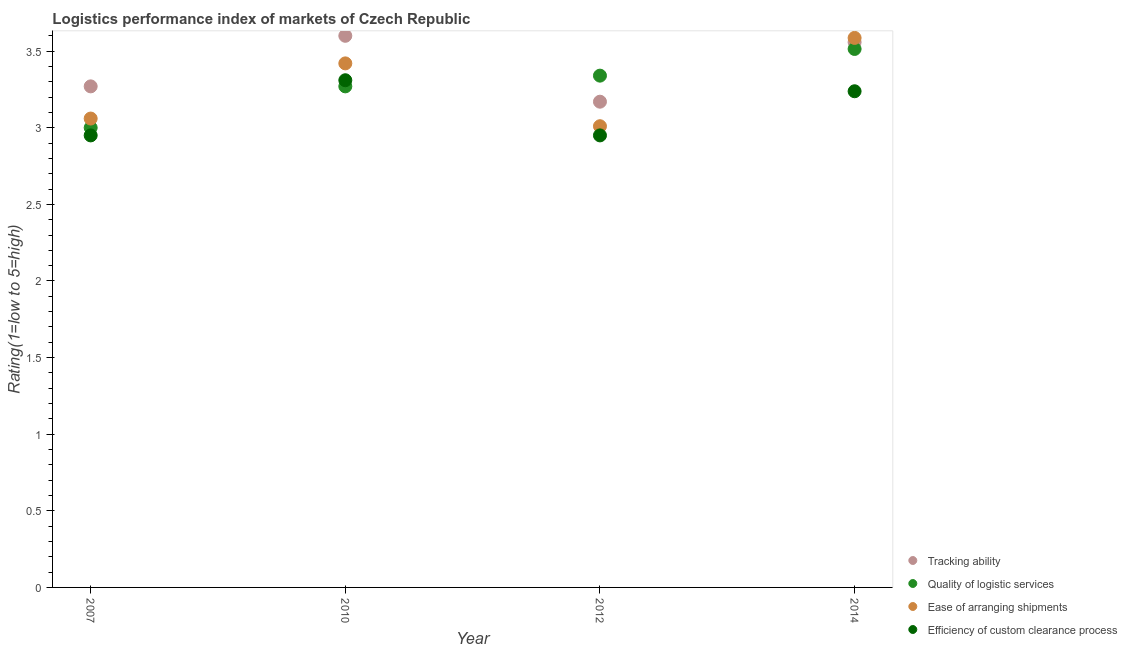How many different coloured dotlines are there?
Keep it short and to the point. 4. What is the lpi rating of efficiency of custom clearance process in 2014?
Provide a succinct answer. 3.24. Across all years, what is the maximum lpi rating of quality of logistic services?
Give a very brief answer. 3.51. In which year was the lpi rating of ease of arranging shipments maximum?
Provide a succinct answer. 2014. What is the total lpi rating of efficiency of custom clearance process in the graph?
Ensure brevity in your answer.  12.45. What is the difference between the lpi rating of tracking ability in 2007 and that in 2014?
Make the answer very short. -0.29. What is the difference between the lpi rating of efficiency of custom clearance process in 2014 and the lpi rating of tracking ability in 2012?
Your response must be concise. 0.07. What is the average lpi rating of quality of logistic services per year?
Your answer should be very brief. 3.28. In the year 2007, what is the difference between the lpi rating of quality of logistic services and lpi rating of tracking ability?
Provide a succinct answer. -0.27. What is the ratio of the lpi rating of efficiency of custom clearance process in 2012 to that in 2014?
Offer a terse response. 0.91. Is the lpi rating of efficiency of custom clearance process in 2007 less than that in 2012?
Offer a terse response. No. Is the difference between the lpi rating of ease of arranging shipments in 2007 and 2010 greater than the difference between the lpi rating of quality of logistic services in 2007 and 2010?
Offer a very short reply. No. What is the difference between the highest and the second highest lpi rating of quality of logistic services?
Keep it short and to the point. 0.17. What is the difference between the highest and the lowest lpi rating of efficiency of custom clearance process?
Make the answer very short. 0.36. Is the sum of the lpi rating of ease of arranging shipments in 2010 and 2012 greater than the maximum lpi rating of quality of logistic services across all years?
Ensure brevity in your answer.  Yes. Is it the case that in every year, the sum of the lpi rating of quality of logistic services and lpi rating of efficiency of custom clearance process is greater than the sum of lpi rating of tracking ability and lpi rating of ease of arranging shipments?
Give a very brief answer. No. Is it the case that in every year, the sum of the lpi rating of tracking ability and lpi rating of quality of logistic services is greater than the lpi rating of ease of arranging shipments?
Your answer should be very brief. Yes. Does the lpi rating of quality of logistic services monotonically increase over the years?
Provide a succinct answer. Yes. Is the lpi rating of tracking ability strictly less than the lpi rating of ease of arranging shipments over the years?
Your answer should be very brief. No. How many dotlines are there?
Provide a succinct answer. 4. What is the difference between two consecutive major ticks on the Y-axis?
Your response must be concise. 0.5. Does the graph contain any zero values?
Keep it short and to the point. No. Where does the legend appear in the graph?
Offer a terse response. Bottom right. How are the legend labels stacked?
Your answer should be very brief. Vertical. What is the title of the graph?
Keep it short and to the point. Logistics performance index of markets of Czech Republic. What is the label or title of the Y-axis?
Ensure brevity in your answer.  Rating(1=low to 5=high). What is the Rating(1=low to 5=high) of Tracking ability in 2007?
Provide a succinct answer. 3.27. What is the Rating(1=low to 5=high) of Quality of logistic services in 2007?
Your answer should be compact. 3. What is the Rating(1=low to 5=high) of Ease of arranging shipments in 2007?
Give a very brief answer. 3.06. What is the Rating(1=low to 5=high) of Efficiency of custom clearance process in 2007?
Ensure brevity in your answer.  2.95. What is the Rating(1=low to 5=high) of Quality of logistic services in 2010?
Provide a succinct answer. 3.27. What is the Rating(1=low to 5=high) in Ease of arranging shipments in 2010?
Your answer should be compact. 3.42. What is the Rating(1=low to 5=high) of Efficiency of custom clearance process in 2010?
Offer a very short reply. 3.31. What is the Rating(1=low to 5=high) of Tracking ability in 2012?
Offer a very short reply. 3.17. What is the Rating(1=low to 5=high) of Quality of logistic services in 2012?
Your response must be concise. 3.34. What is the Rating(1=low to 5=high) in Ease of arranging shipments in 2012?
Make the answer very short. 3.01. What is the Rating(1=low to 5=high) of Efficiency of custom clearance process in 2012?
Offer a very short reply. 2.95. What is the Rating(1=low to 5=high) of Tracking ability in 2014?
Offer a very short reply. 3.56. What is the Rating(1=low to 5=high) of Quality of logistic services in 2014?
Your answer should be compact. 3.51. What is the Rating(1=low to 5=high) of Ease of arranging shipments in 2014?
Offer a terse response. 3.59. What is the Rating(1=low to 5=high) of Efficiency of custom clearance process in 2014?
Your answer should be compact. 3.24. Across all years, what is the maximum Rating(1=low to 5=high) in Quality of logistic services?
Offer a very short reply. 3.51. Across all years, what is the maximum Rating(1=low to 5=high) in Ease of arranging shipments?
Give a very brief answer. 3.59. Across all years, what is the maximum Rating(1=low to 5=high) in Efficiency of custom clearance process?
Offer a very short reply. 3.31. Across all years, what is the minimum Rating(1=low to 5=high) in Tracking ability?
Your answer should be compact. 3.17. Across all years, what is the minimum Rating(1=low to 5=high) of Quality of logistic services?
Your response must be concise. 3. Across all years, what is the minimum Rating(1=low to 5=high) in Ease of arranging shipments?
Keep it short and to the point. 3.01. Across all years, what is the minimum Rating(1=low to 5=high) of Efficiency of custom clearance process?
Offer a very short reply. 2.95. What is the total Rating(1=low to 5=high) in Tracking ability in the graph?
Keep it short and to the point. 13.6. What is the total Rating(1=low to 5=high) of Quality of logistic services in the graph?
Keep it short and to the point. 13.12. What is the total Rating(1=low to 5=high) in Ease of arranging shipments in the graph?
Offer a terse response. 13.08. What is the total Rating(1=low to 5=high) in Efficiency of custom clearance process in the graph?
Offer a terse response. 12.45. What is the difference between the Rating(1=low to 5=high) in Tracking ability in 2007 and that in 2010?
Your response must be concise. -0.33. What is the difference between the Rating(1=low to 5=high) in Quality of logistic services in 2007 and that in 2010?
Your answer should be very brief. -0.27. What is the difference between the Rating(1=low to 5=high) in Ease of arranging shipments in 2007 and that in 2010?
Give a very brief answer. -0.36. What is the difference between the Rating(1=low to 5=high) of Efficiency of custom clearance process in 2007 and that in 2010?
Make the answer very short. -0.36. What is the difference between the Rating(1=low to 5=high) in Quality of logistic services in 2007 and that in 2012?
Ensure brevity in your answer.  -0.34. What is the difference between the Rating(1=low to 5=high) in Ease of arranging shipments in 2007 and that in 2012?
Your answer should be very brief. 0.05. What is the difference between the Rating(1=low to 5=high) in Efficiency of custom clearance process in 2007 and that in 2012?
Provide a short and direct response. 0. What is the difference between the Rating(1=low to 5=high) of Tracking ability in 2007 and that in 2014?
Provide a short and direct response. -0.29. What is the difference between the Rating(1=low to 5=high) in Quality of logistic services in 2007 and that in 2014?
Offer a very short reply. -0.51. What is the difference between the Rating(1=low to 5=high) in Ease of arranging shipments in 2007 and that in 2014?
Your answer should be compact. -0.53. What is the difference between the Rating(1=low to 5=high) of Efficiency of custom clearance process in 2007 and that in 2014?
Make the answer very short. -0.29. What is the difference between the Rating(1=low to 5=high) in Tracking ability in 2010 and that in 2012?
Your answer should be compact. 0.43. What is the difference between the Rating(1=low to 5=high) in Quality of logistic services in 2010 and that in 2012?
Provide a short and direct response. -0.07. What is the difference between the Rating(1=low to 5=high) of Ease of arranging shipments in 2010 and that in 2012?
Offer a very short reply. 0.41. What is the difference between the Rating(1=low to 5=high) in Efficiency of custom clearance process in 2010 and that in 2012?
Your answer should be very brief. 0.36. What is the difference between the Rating(1=low to 5=high) in Tracking ability in 2010 and that in 2014?
Make the answer very short. 0.04. What is the difference between the Rating(1=low to 5=high) of Quality of logistic services in 2010 and that in 2014?
Your response must be concise. -0.24. What is the difference between the Rating(1=low to 5=high) in Ease of arranging shipments in 2010 and that in 2014?
Ensure brevity in your answer.  -0.17. What is the difference between the Rating(1=low to 5=high) in Efficiency of custom clearance process in 2010 and that in 2014?
Your answer should be compact. 0.07. What is the difference between the Rating(1=low to 5=high) in Tracking ability in 2012 and that in 2014?
Provide a short and direct response. -0.39. What is the difference between the Rating(1=low to 5=high) of Quality of logistic services in 2012 and that in 2014?
Offer a terse response. -0.17. What is the difference between the Rating(1=low to 5=high) in Ease of arranging shipments in 2012 and that in 2014?
Your answer should be very brief. -0.58. What is the difference between the Rating(1=low to 5=high) in Efficiency of custom clearance process in 2012 and that in 2014?
Provide a succinct answer. -0.29. What is the difference between the Rating(1=low to 5=high) of Tracking ability in 2007 and the Rating(1=low to 5=high) of Ease of arranging shipments in 2010?
Offer a terse response. -0.15. What is the difference between the Rating(1=low to 5=high) in Tracking ability in 2007 and the Rating(1=low to 5=high) in Efficiency of custom clearance process in 2010?
Ensure brevity in your answer.  -0.04. What is the difference between the Rating(1=low to 5=high) in Quality of logistic services in 2007 and the Rating(1=low to 5=high) in Ease of arranging shipments in 2010?
Ensure brevity in your answer.  -0.42. What is the difference between the Rating(1=low to 5=high) of Quality of logistic services in 2007 and the Rating(1=low to 5=high) of Efficiency of custom clearance process in 2010?
Your response must be concise. -0.31. What is the difference between the Rating(1=low to 5=high) in Tracking ability in 2007 and the Rating(1=low to 5=high) in Quality of logistic services in 2012?
Your response must be concise. -0.07. What is the difference between the Rating(1=low to 5=high) in Tracking ability in 2007 and the Rating(1=low to 5=high) in Ease of arranging shipments in 2012?
Your answer should be very brief. 0.26. What is the difference between the Rating(1=low to 5=high) of Tracking ability in 2007 and the Rating(1=low to 5=high) of Efficiency of custom clearance process in 2012?
Give a very brief answer. 0.32. What is the difference between the Rating(1=low to 5=high) of Quality of logistic services in 2007 and the Rating(1=low to 5=high) of Ease of arranging shipments in 2012?
Offer a terse response. -0.01. What is the difference between the Rating(1=low to 5=high) of Ease of arranging shipments in 2007 and the Rating(1=low to 5=high) of Efficiency of custom clearance process in 2012?
Your answer should be compact. 0.11. What is the difference between the Rating(1=low to 5=high) of Tracking ability in 2007 and the Rating(1=low to 5=high) of Quality of logistic services in 2014?
Provide a short and direct response. -0.24. What is the difference between the Rating(1=low to 5=high) of Tracking ability in 2007 and the Rating(1=low to 5=high) of Ease of arranging shipments in 2014?
Your answer should be very brief. -0.32. What is the difference between the Rating(1=low to 5=high) of Tracking ability in 2007 and the Rating(1=low to 5=high) of Efficiency of custom clearance process in 2014?
Offer a very short reply. 0.03. What is the difference between the Rating(1=low to 5=high) in Quality of logistic services in 2007 and the Rating(1=low to 5=high) in Ease of arranging shipments in 2014?
Your response must be concise. -0.59. What is the difference between the Rating(1=low to 5=high) in Quality of logistic services in 2007 and the Rating(1=low to 5=high) in Efficiency of custom clearance process in 2014?
Ensure brevity in your answer.  -0.24. What is the difference between the Rating(1=low to 5=high) of Ease of arranging shipments in 2007 and the Rating(1=low to 5=high) of Efficiency of custom clearance process in 2014?
Your answer should be very brief. -0.18. What is the difference between the Rating(1=low to 5=high) of Tracking ability in 2010 and the Rating(1=low to 5=high) of Quality of logistic services in 2012?
Offer a terse response. 0.26. What is the difference between the Rating(1=low to 5=high) in Tracking ability in 2010 and the Rating(1=low to 5=high) in Ease of arranging shipments in 2012?
Give a very brief answer. 0.59. What is the difference between the Rating(1=low to 5=high) in Tracking ability in 2010 and the Rating(1=low to 5=high) in Efficiency of custom clearance process in 2012?
Offer a very short reply. 0.65. What is the difference between the Rating(1=low to 5=high) in Quality of logistic services in 2010 and the Rating(1=low to 5=high) in Ease of arranging shipments in 2012?
Offer a very short reply. 0.26. What is the difference between the Rating(1=low to 5=high) in Quality of logistic services in 2010 and the Rating(1=low to 5=high) in Efficiency of custom clearance process in 2012?
Your answer should be compact. 0.32. What is the difference between the Rating(1=low to 5=high) in Ease of arranging shipments in 2010 and the Rating(1=low to 5=high) in Efficiency of custom clearance process in 2012?
Provide a short and direct response. 0.47. What is the difference between the Rating(1=low to 5=high) of Tracking ability in 2010 and the Rating(1=low to 5=high) of Quality of logistic services in 2014?
Offer a terse response. 0.09. What is the difference between the Rating(1=low to 5=high) in Tracking ability in 2010 and the Rating(1=low to 5=high) in Ease of arranging shipments in 2014?
Your response must be concise. 0.01. What is the difference between the Rating(1=low to 5=high) of Tracking ability in 2010 and the Rating(1=low to 5=high) of Efficiency of custom clearance process in 2014?
Make the answer very short. 0.36. What is the difference between the Rating(1=low to 5=high) of Quality of logistic services in 2010 and the Rating(1=low to 5=high) of Ease of arranging shipments in 2014?
Keep it short and to the point. -0.32. What is the difference between the Rating(1=low to 5=high) of Quality of logistic services in 2010 and the Rating(1=low to 5=high) of Efficiency of custom clearance process in 2014?
Your answer should be very brief. 0.03. What is the difference between the Rating(1=low to 5=high) in Ease of arranging shipments in 2010 and the Rating(1=low to 5=high) in Efficiency of custom clearance process in 2014?
Provide a succinct answer. 0.18. What is the difference between the Rating(1=low to 5=high) of Tracking ability in 2012 and the Rating(1=low to 5=high) of Quality of logistic services in 2014?
Your answer should be compact. -0.34. What is the difference between the Rating(1=low to 5=high) in Tracking ability in 2012 and the Rating(1=low to 5=high) in Ease of arranging shipments in 2014?
Your response must be concise. -0.42. What is the difference between the Rating(1=low to 5=high) of Tracking ability in 2012 and the Rating(1=low to 5=high) of Efficiency of custom clearance process in 2014?
Your response must be concise. -0.07. What is the difference between the Rating(1=low to 5=high) in Quality of logistic services in 2012 and the Rating(1=low to 5=high) in Ease of arranging shipments in 2014?
Make the answer very short. -0.25. What is the difference between the Rating(1=low to 5=high) of Quality of logistic services in 2012 and the Rating(1=low to 5=high) of Efficiency of custom clearance process in 2014?
Make the answer very short. 0.1. What is the difference between the Rating(1=low to 5=high) in Ease of arranging shipments in 2012 and the Rating(1=low to 5=high) in Efficiency of custom clearance process in 2014?
Your response must be concise. -0.23. What is the average Rating(1=low to 5=high) of Tracking ability per year?
Offer a terse response. 3.4. What is the average Rating(1=low to 5=high) of Quality of logistic services per year?
Offer a terse response. 3.28. What is the average Rating(1=low to 5=high) in Ease of arranging shipments per year?
Ensure brevity in your answer.  3.27. What is the average Rating(1=low to 5=high) in Efficiency of custom clearance process per year?
Offer a terse response. 3.11. In the year 2007, what is the difference between the Rating(1=low to 5=high) in Tracking ability and Rating(1=low to 5=high) in Quality of logistic services?
Your response must be concise. 0.27. In the year 2007, what is the difference between the Rating(1=low to 5=high) in Tracking ability and Rating(1=low to 5=high) in Ease of arranging shipments?
Keep it short and to the point. 0.21. In the year 2007, what is the difference between the Rating(1=low to 5=high) of Tracking ability and Rating(1=low to 5=high) of Efficiency of custom clearance process?
Your answer should be very brief. 0.32. In the year 2007, what is the difference between the Rating(1=low to 5=high) of Quality of logistic services and Rating(1=low to 5=high) of Ease of arranging shipments?
Offer a terse response. -0.06. In the year 2007, what is the difference between the Rating(1=low to 5=high) in Quality of logistic services and Rating(1=low to 5=high) in Efficiency of custom clearance process?
Provide a short and direct response. 0.05. In the year 2007, what is the difference between the Rating(1=low to 5=high) in Ease of arranging shipments and Rating(1=low to 5=high) in Efficiency of custom clearance process?
Offer a terse response. 0.11. In the year 2010, what is the difference between the Rating(1=low to 5=high) in Tracking ability and Rating(1=low to 5=high) in Quality of logistic services?
Give a very brief answer. 0.33. In the year 2010, what is the difference between the Rating(1=low to 5=high) of Tracking ability and Rating(1=low to 5=high) of Ease of arranging shipments?
Give a very brief answer. 0.18. In the year 2010, what is the difference between the Rating(1=low to 5=high) of Tracking ability and Rating(1=low to 5=high) of Efficiency of custom clearance process?
Keep it short and to the point. 0.29. In the year 2010, what is the difference between the Rating(1=low to 5=high) in Quality of logistic services and Rating(1=low to 5=high) in Ease of arranging shipments?
Offer a very short reply. -0.15. In the year 2010, what is the difference between the Rating(1=low to 5=high) of Quality of logistic services and Rating(1=low to 5=high) of Efficiency of custom clearance process?
Keep it short and to the point. -0.04. In the year 2010, what is the difference between the Rating(1=low to 5=high) in Ease of arranging shipments and Rating(1=low to 5=high) in Efficiency of custom clearance process?
Provide a succinct answer. 0.11. In the year 2012, what is the difference between the Rating(1=low to 5=high) in Tracking ability and Rating(1=low to 5=high) in Quality of logistic services?
Make the answer very short. -0.17. In the year 2012, what is the difference between the Rating(1=low to 5=high) in Tracking ability and Rating(1=low to 5=high) in Ease of arranging shipments?
Provide a short and direct response. 0.16. In the year 2012, what is the difference between the Rating(1=low to 5=high) of Tracking ability and Rating(1=low to 5=high) of Efficiency of custom clearance process?
Offer a terse response. 0.22. In the year 2012, what is the difference between the Rating(1=low to 5=high) in Quality of logistic services and Rating(1=low to 5=high) in Ease of arranging shipments?
Offer a terse response. 0.33. In the year 2012, what is the difference between the Rating(1=low to 5=high) in Quality of logistic services and Rating(1=low to 5=high) in Efficiency of custom clearance process?
Your answer should be very brief. 0.39. In the year 2012, what is the difference between the Rating(1=low to 5=high) of Ease of arranging shipments and Rating(1=low to 5=high) of Efficiency of custom clearance process?
Offer a terse response. 0.06. In the year 2014, what is the difference between the Rating(1=low to 5=high) in Tracking ability and Rating(1=low to 5=high) in Quality of logistic services?
Offer a very short reply. 0.04. In the year 2014, what is the difference between the Rating(1=low to 5=high) in Tracking ability and Rating(1=low to 5=high) in Ease of arranging shipments?
Your answer should be very brief. -0.03. In the year 2014, what is the difference between the Rating(1=low to 5=high) of Tracking ability and Rating(1=low to 5=high) of Efficiency of custom clearance process?
Offer a terse response. 0.32. In the year 2014, what is the difference between the Rating(1=low to 5=high) of Quality of logistic services and Rating(1=low to 5=high) of Ease of arranging shipments?
Provide a succinct answer. -0.07. In the year 2014, what is the difference between the Rating(1=low to 5=high) of Quality of logistic services and Rating(1=low to 5=high) of Efficiency of custom clearance process?
Ensure brevity in your answer.  0.28. In the year 2014, what is the difference between the Rating(1=low to 5=high) in Ease of arranging shipments and Rating(1=low to 5=high) in Efficiency of custom clearance process?
Your answer should be compact. 0.35. What is the ratio of the Rating(1=low to 5=high) of Tracking ability in 2007 to that in 2010?
Provide a succinct answer. 0.91. What is the ratio of the Rating(1=low to 5=high) of Quality of logistic services in 2007 to that in 2010?
Your answer should be very brief. 0.92. What is the ratio of the Rating(1=low to 5=high) of Ease of arranging shipments in 2007 to that in 2010?
Offer a very short reply. 0.89. What is the ratio of the Rating(1=low to 5=high) in Efficiency of custom clearance process in 2007 to that in 2010?
Keep it short and to the point. 0.89. What is the ratio of the Rating(1=low to 5=high) in Tracking ability in 2007 to that in 2012?
Your answer should be compact. 1.03. What is the ratio of the Rating(1=low to 5=high) of Quality of logistic services in 2007 to that in 2012?
Offer a terse response. 0.9. What is the ratio of the Rating(1=low to 5=high) of Ease of arranging shipments in 2007 to that in 2012?
Give a very brief answer. 1.02. What is the ratio of the Rating(1=low to 5=high) of Efficiency of custom clearance process in 2007 to that in 2012?
Provide a succinct answer. 1. What is the ratio of the Rating(1=low to 5=high) in Tracking ability in 2007 to that in 2014?
Keep it short and to the point. 0.92. What is the ratio of the Rating(1=low to 5=high) of Quality of logistic services in 2007 to that in 2014?
Ensure brevity in your answer.  0.85. What is the ratio of the Rating(1=low to 5=high) of Ease of arranging shipments in 2007 to that in 2014?
Give a very brief answer. 0.85. What is the ratio of the Rating(1=low to 5=high) in Efficiency of custom clearance process in 2007 to that in 2014?
Your response must be concise. 0.91. What is the ratio of the Rating(1=low to 5=high) of Tracking ability in 2010 to that in 2012?
Give a very brief answer. 1.14. What is the ratio of the Rating(1=low to 5=high) of Ease of arranging shipments in 2010 to that in 2012?
Make the answer very short. 1.14. What is the ratio of the Rating(1=low to 5=high) in Efficiency of custom clearance process in 2010 to that in 2012?
Offer a terse response. 1.12. What is the ratio of the Rating(1=low to 5=high) in Tracking ability in 2010 to that in 2014?
Keep it short and to the point. 1.01. What is the ratio of the Rating(1=low to 5=high) in Quality of logistic services in 2010 to that in 2014?
Make the answer very short. 0.93. What is the ratio of the Rating(1=low to 5=high) in Ease of arranging shipments in 2010 to that in 2014?
Make the answer very short. 0.95. What is the ratio of the Rating(1=low to 5=high) in Efficiency of custom clearance process in 2010 to that in 2014?
Keep it short and to the point. 1.02. What is the ratio of the Rating(1=low to 5=high) in Tracking ability in 2012 to that in 2014?
Ensure brevity in your answer.  0.89. What is the ratio of the Rating(1=low to 5=high) in Quality of logistic services in 2012 to that in 2014?
Provide a succinct answer. 0.95. What is the ratio of the Rating(1=low to 5=high) of Ease of arranging shipments in 2012 to that in 2014?
Your response must be concise. 0.84. What is the ratio of the Rating(1=low to 5=high) in Efficiency of custom clearance process in 2012 to that in 2014?
Your answer should be very brief. 0.91. What is the difference between the highest and the second highest Rating(1=low to 5=high) in Tracking ability?
Provide a short and direct response. 0.04. What is the difference between the highest and the second highest Rating(1=low to 5=high) in Quality of logistic services?
Your response must be concise. 0.17. What is the difference between the highest and the second highest Rating(1=low to 5=high) in Ease of arranging shipments?
Your answer should be very brief. 0.17. What is the difference between the highest and the second highest Rating(1=low to 5=high) in Efficiency of custom clearance process?
Provide a succinct answer. 0.07. What is the difference between the highest and the lowest Rating(1=low to 5=high) in Tracking ability?
Provide a succinct answer. 0.43. What is the difference between the highest and the lowest Rating(1=low to 5=high) in Quality of logistic services?
Your response must be concise. 0.51. What is the difference between the highest and the lowest Rating(1=low to 5=high) in Ease of arranging shipments?
Ensure brevity in your answer.  0.58. What is the difference between the highest and the lowest Rating(1=low to 5=high) in Efficiency of custom clearance process?
Provide a succinct answer. 0.36. 